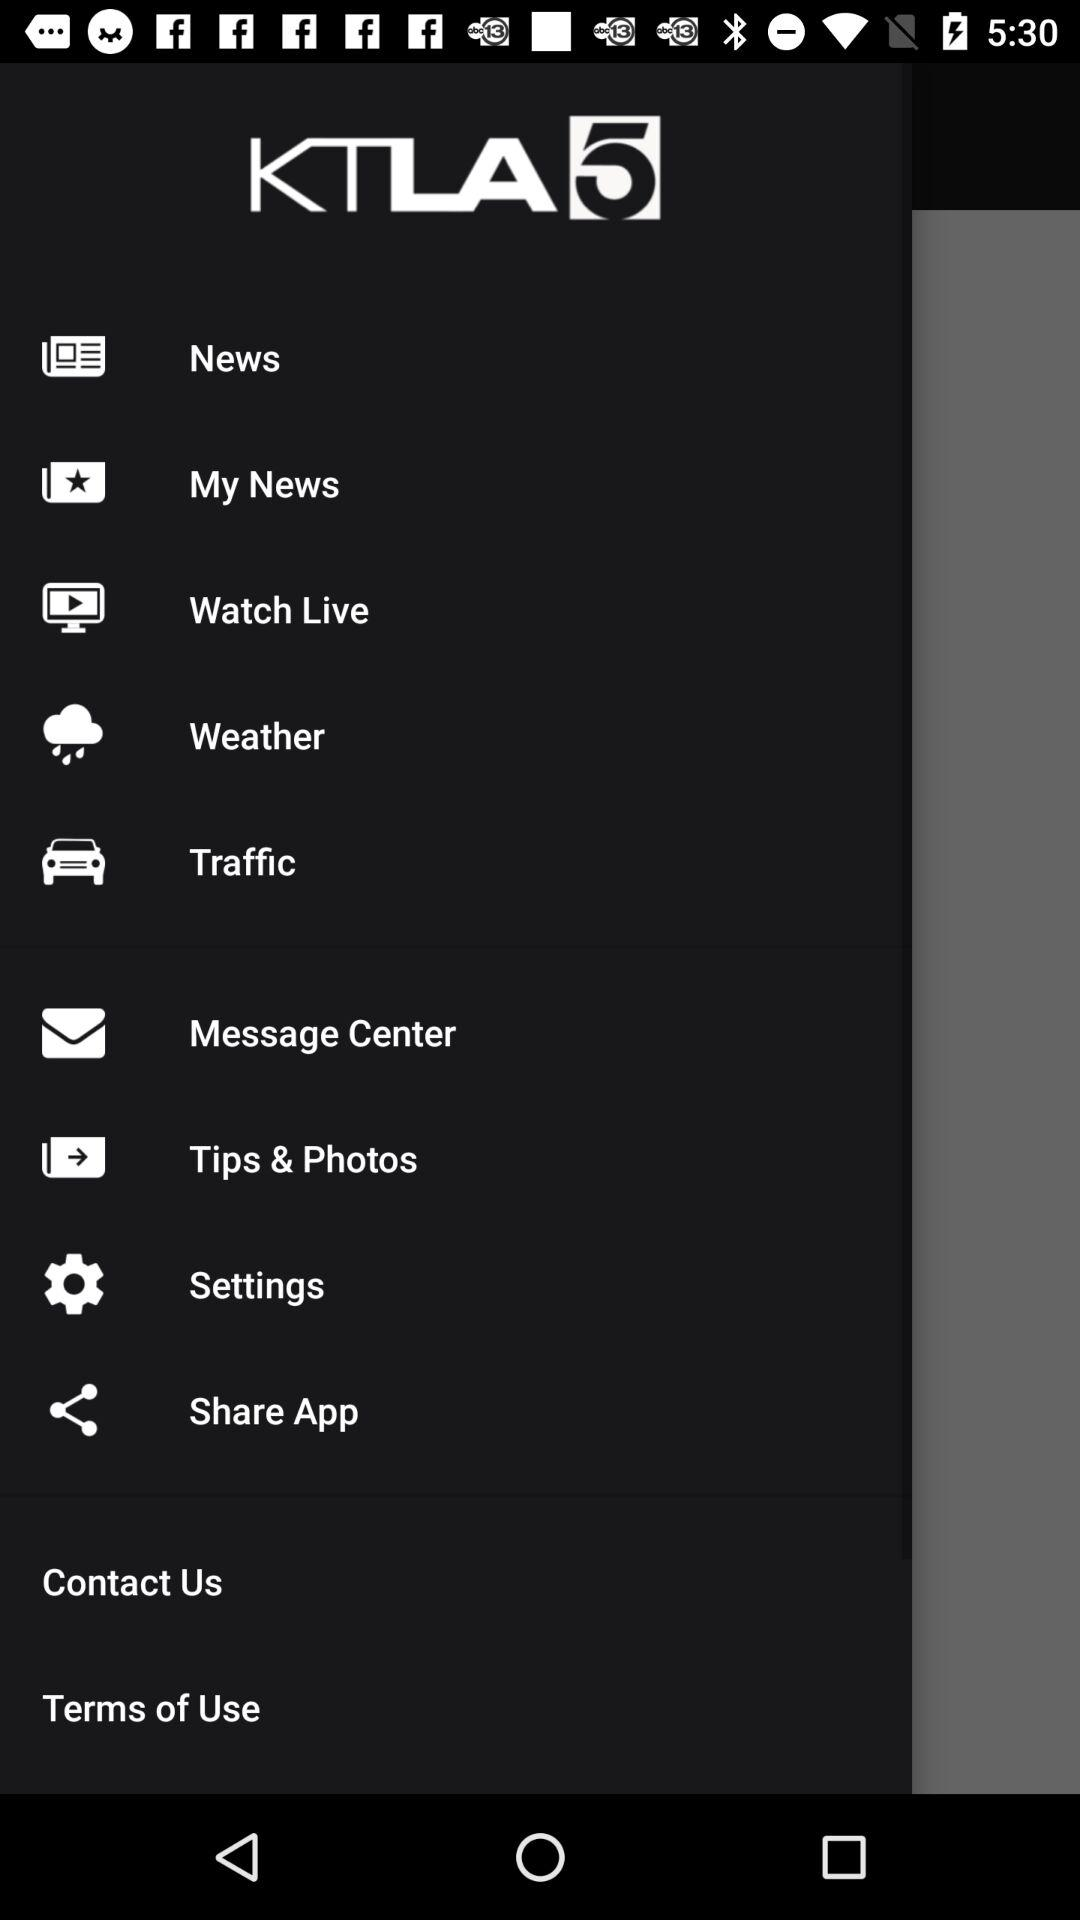What is the name of the application? The name of the application is "KTLA5". 